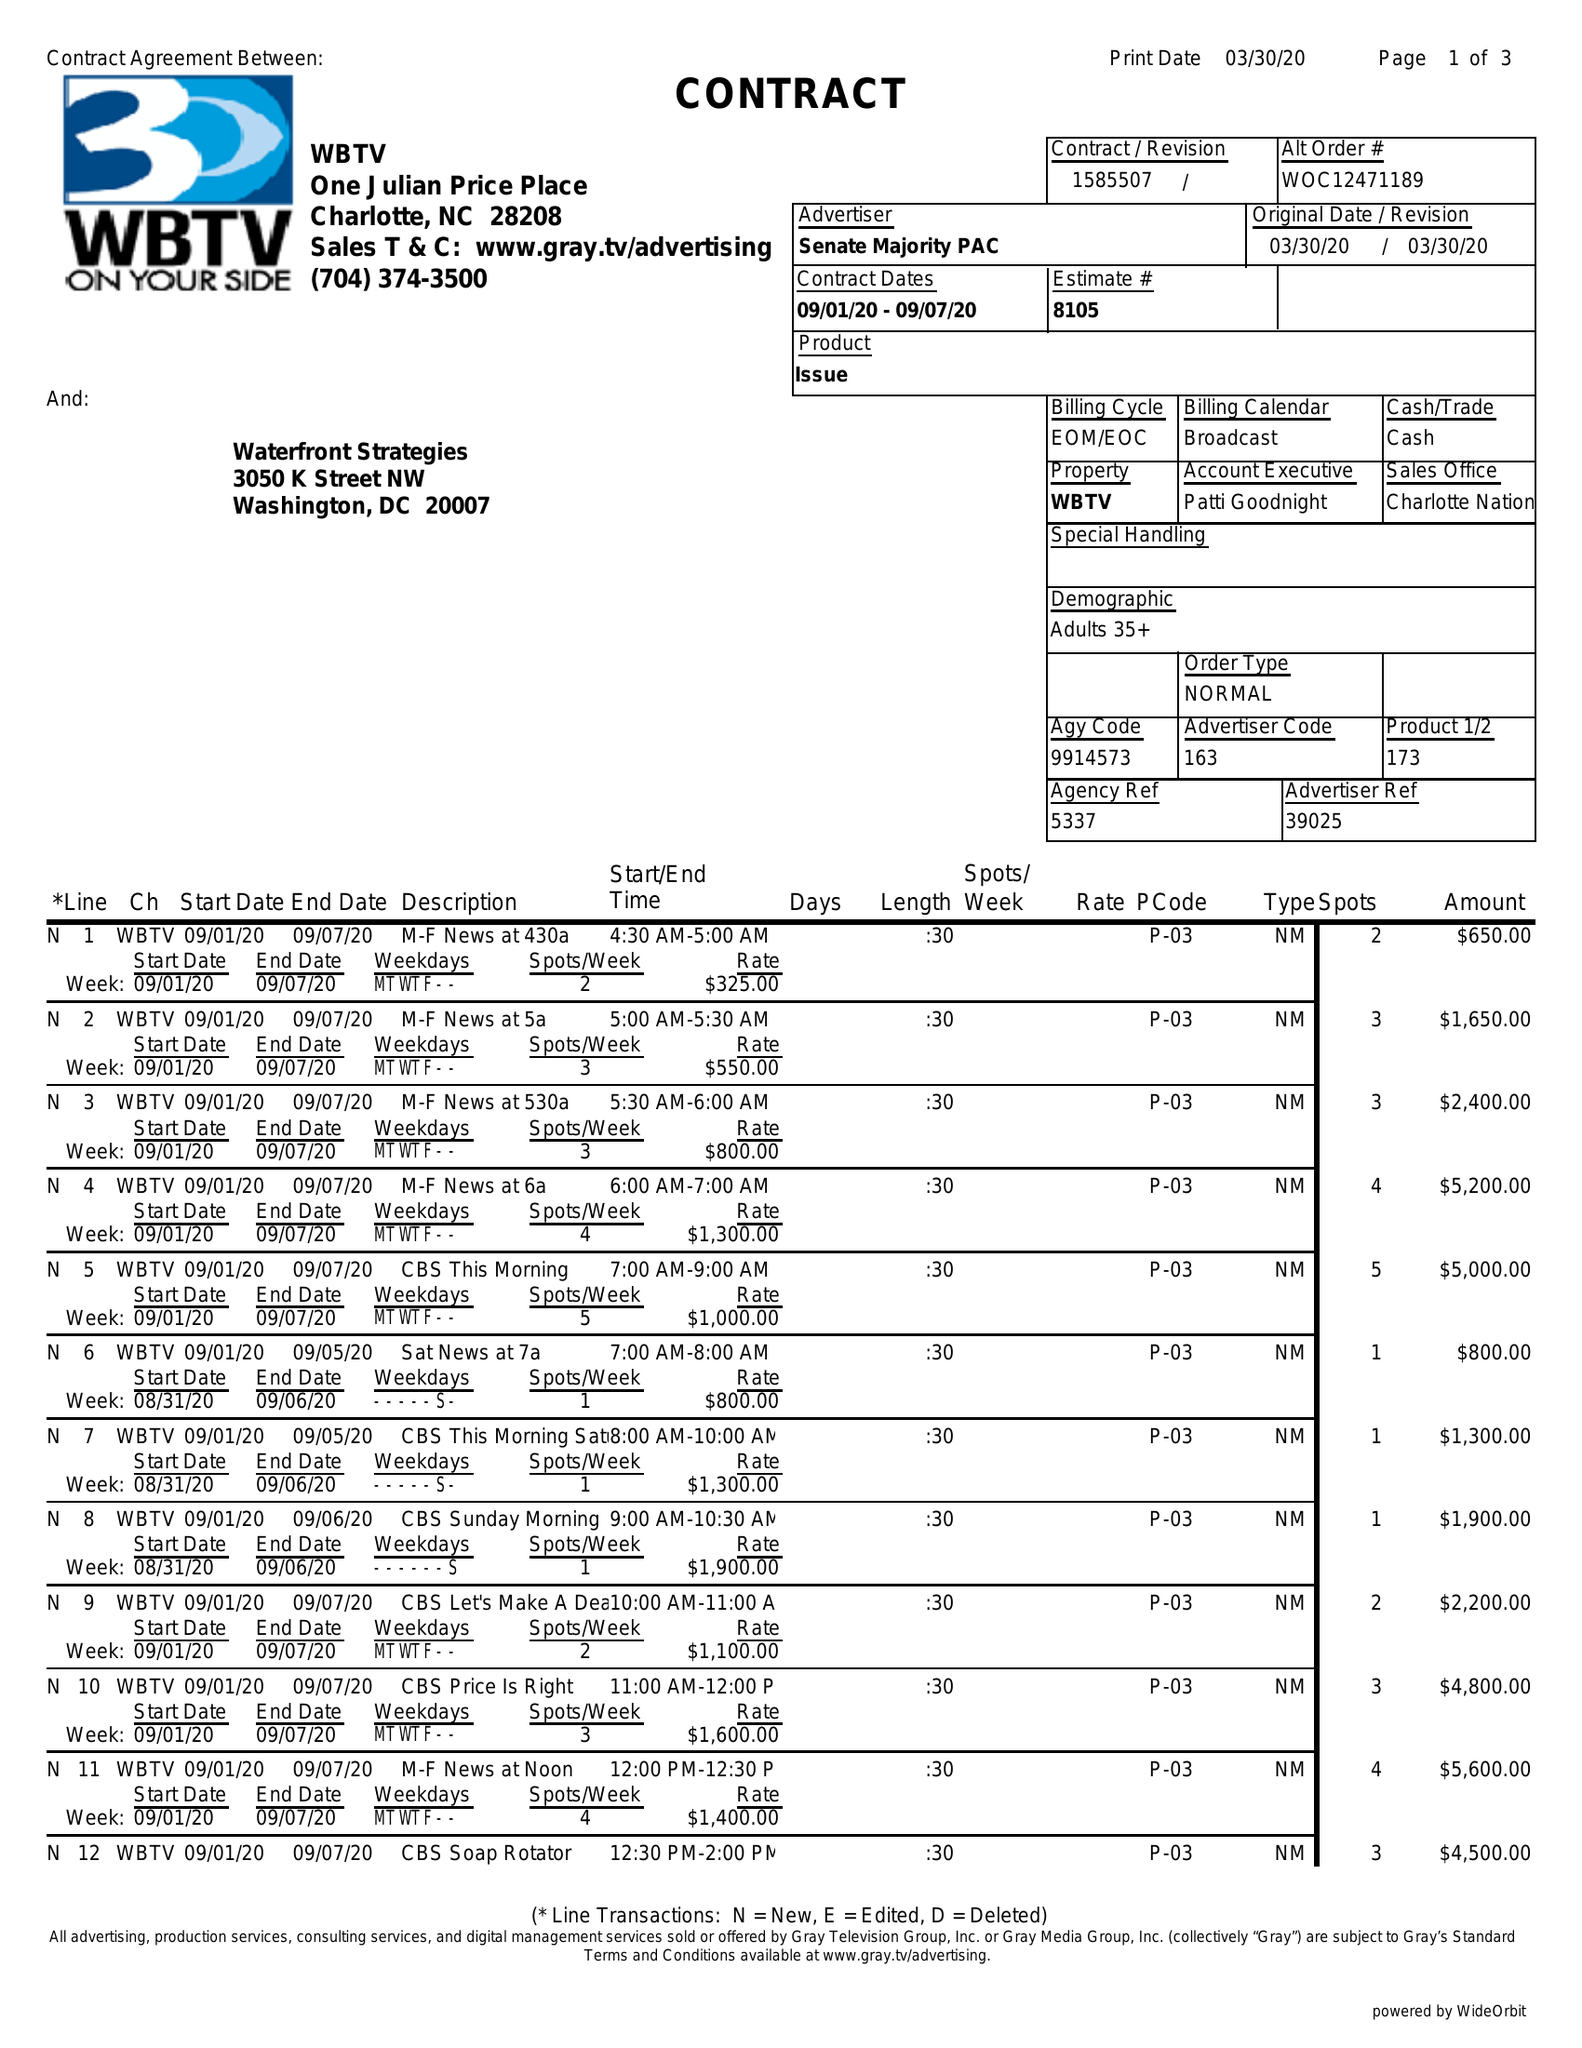What is the value for the flight_to?
Answer the question using a single word or phrase. 09/07/20 